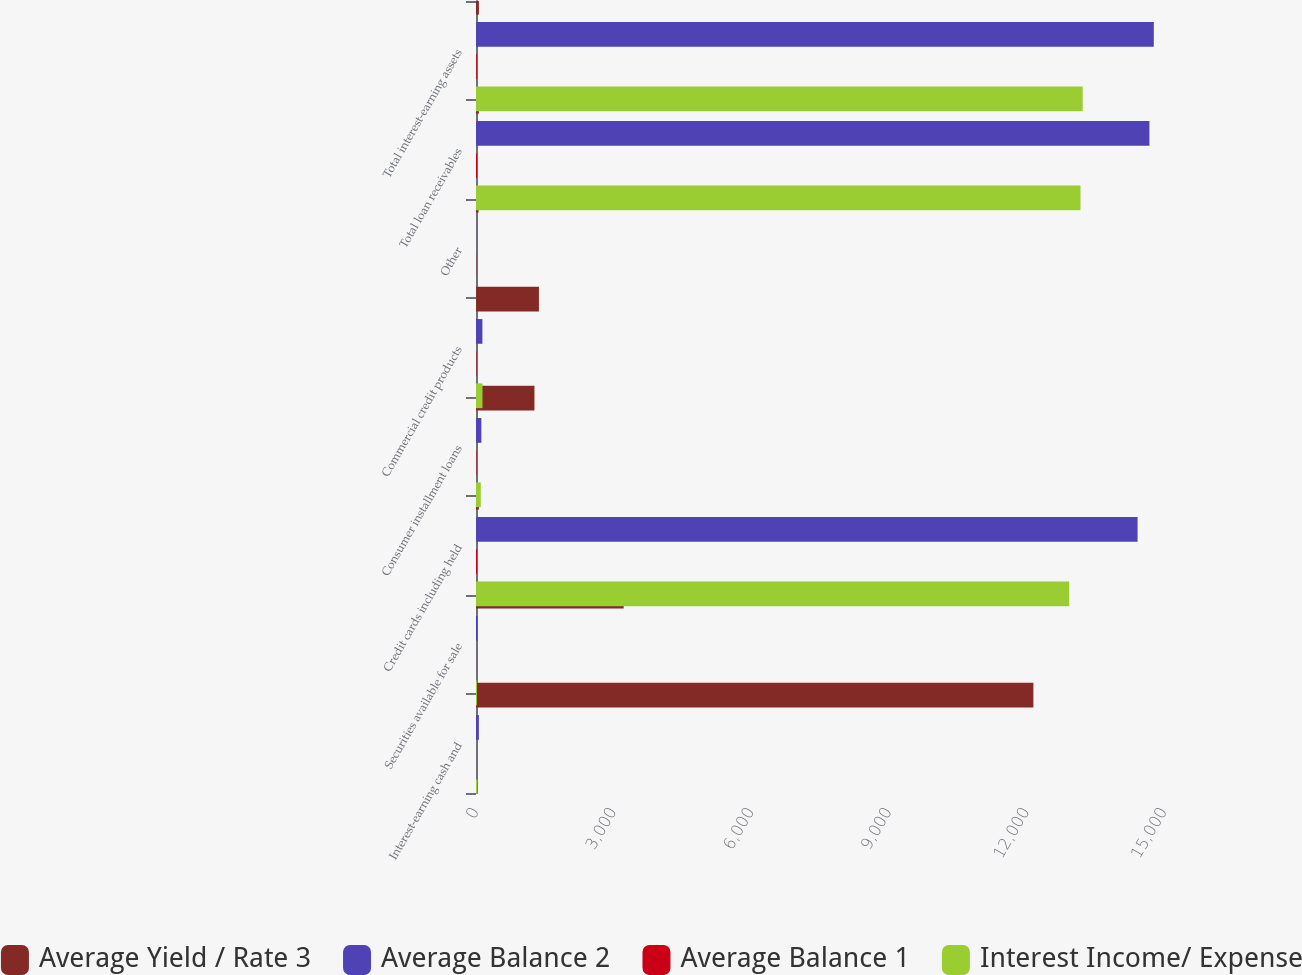<chart> <loc_0><loc_0><loc_500><loc_500><stacked_bar_chart><ecel><fcel>Interest-earning cash and<fcel>Securities available for sale<fcel>Credit cards including held<fcel>Consumer installment loans<fcel>Commercial credit products<fcel>Other<fcel>Total loan receivables<fcel>Total interest-earning assets<nl><fcel>Average Yield / Rate 3<fcel>12152<fcel>3220<fcel>63<fcel>1274<fcel>1372<fcel>56<fcel>63<fcel>63<nl><fcel>Average Balance 2<fcel>63<fcel>33<fcel>14424<fcel>117<fcel>139<fcel>2<fcel>14682<fcel>14778<nl><fcel>Average Balance 1<fcel>0.52<fcel>1.02<fcel>21.87<fcel>9.18<fcel>10.13<fcel>3.57<fcel>21.39<fcel>17.59<nl><fcel>Interest Income/ Expense<fcel>28<fcel>21<fcel>12932<fcel>104<fcel>142<fcel>1<fcel>13179<fcel>13228<nl></chart> 